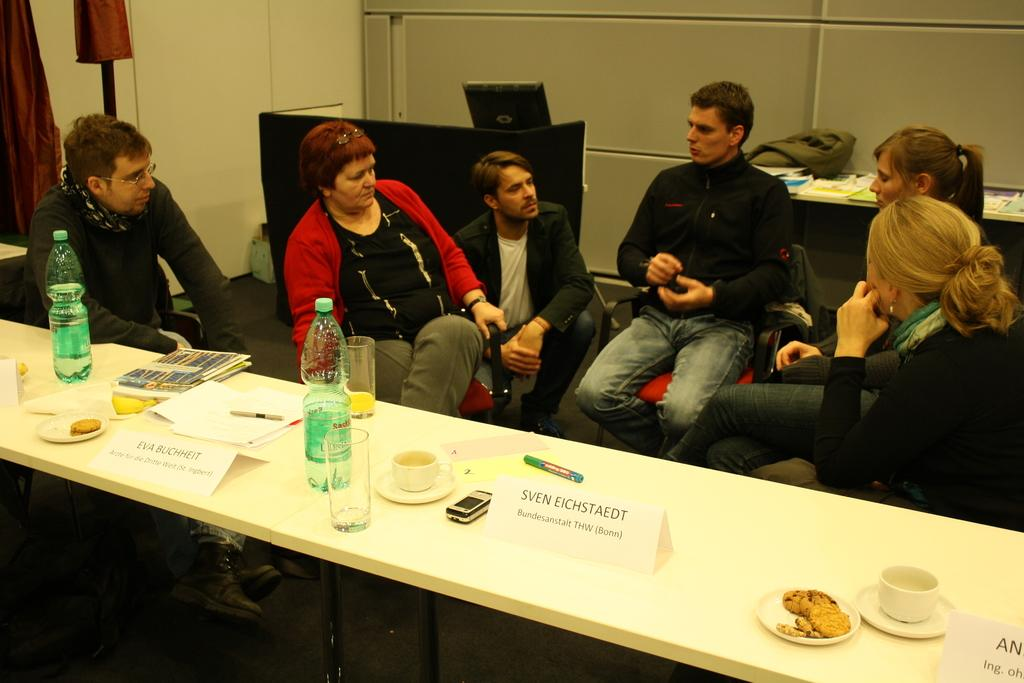What are the people in the image doing? The people in the image are seated. What are the people seated on? The people are seated on chairs. What can be seen on the table in the image? There is a water bottle, glasses, and tea cups on the table. What electronic device is visible in the image? There is a monitor visible in the image. What type of ball is being used by the group in the image? There is no ball present in the image; the group is seated and not engaged in any ball-related activity. 